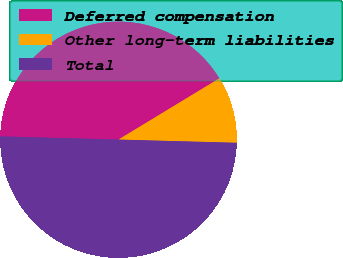<chart> <loc_0><loc_0><loc_500><loc_500><pie_chart><fcel>Deferred compensation<fcel>Other long-term liabilities<fcel>Total<nl><fcel>40.89%<fcel>9.11%<fcel>50.0%<nl></chart> 